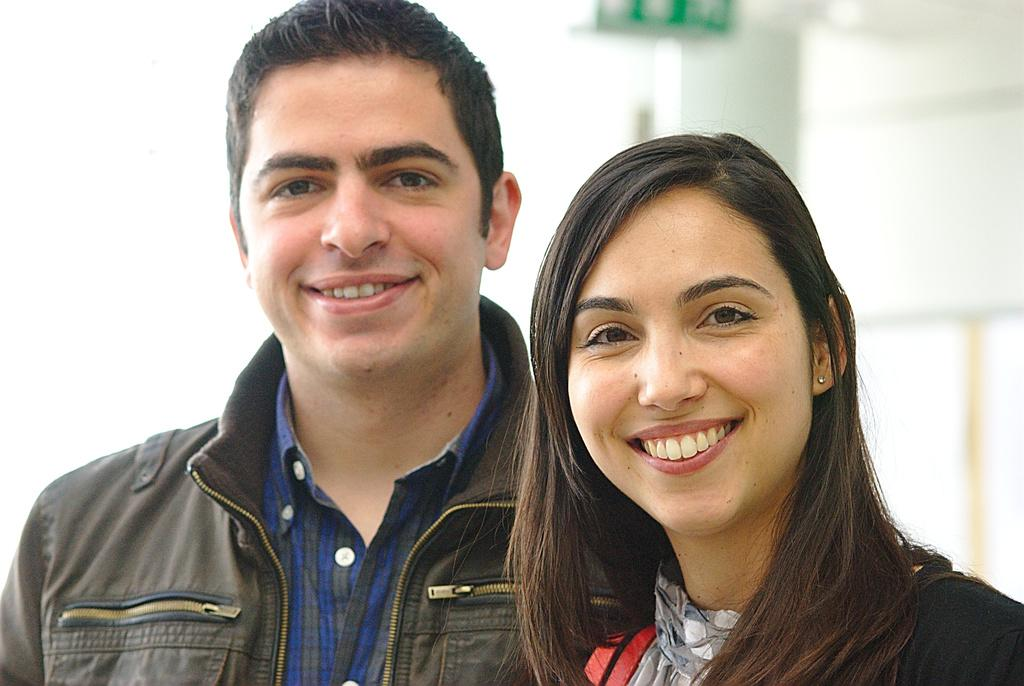What is the gender of the two people in the image? There is a man and a woman in the image. What expressions do the man and woman have in the image? The man is smiling, and the woman is smiling. What type of harmony can be heard in the background of the image? There is no audible harmony present in the image, as it is a still photograph featuring a man and a woman smiling. Can you provide a receipt for the reason the man and woman are smiling in the image? There is no receipt or specific reason provided for the man and woman's smiles in the image; their expressions are simply depicted. 